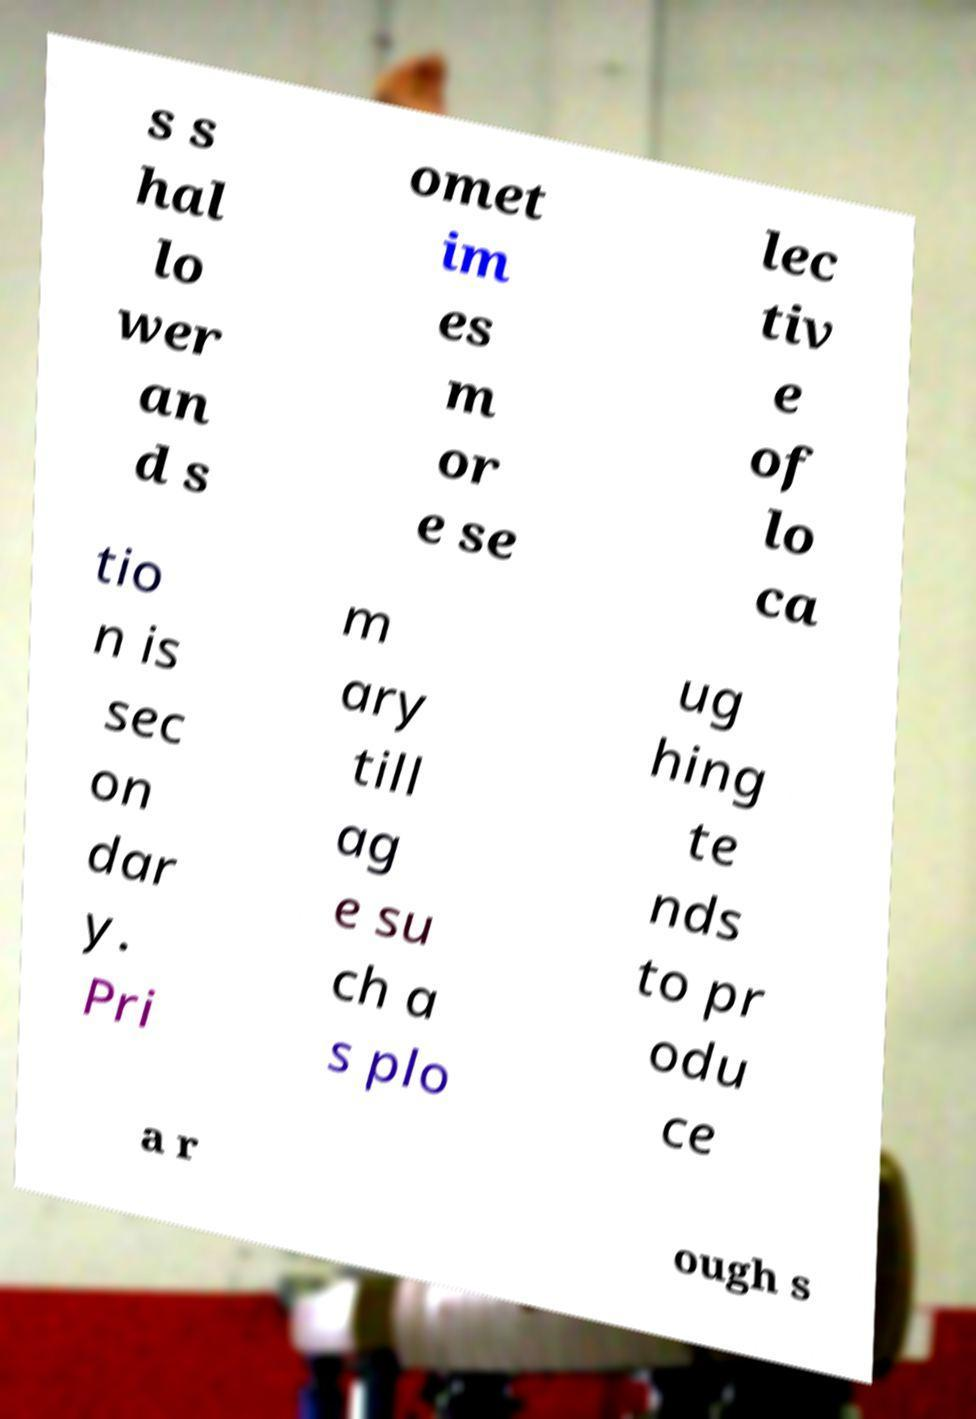Can you accurately transcribe the text from the provided image for me? s s hal lo wer an d s omet im es m or e se lec tiv e of lo ca tio n is sec on dar y. Pri m ary till ag e su ch a s plo ug hing te nds to pr odu ce a r ough s 